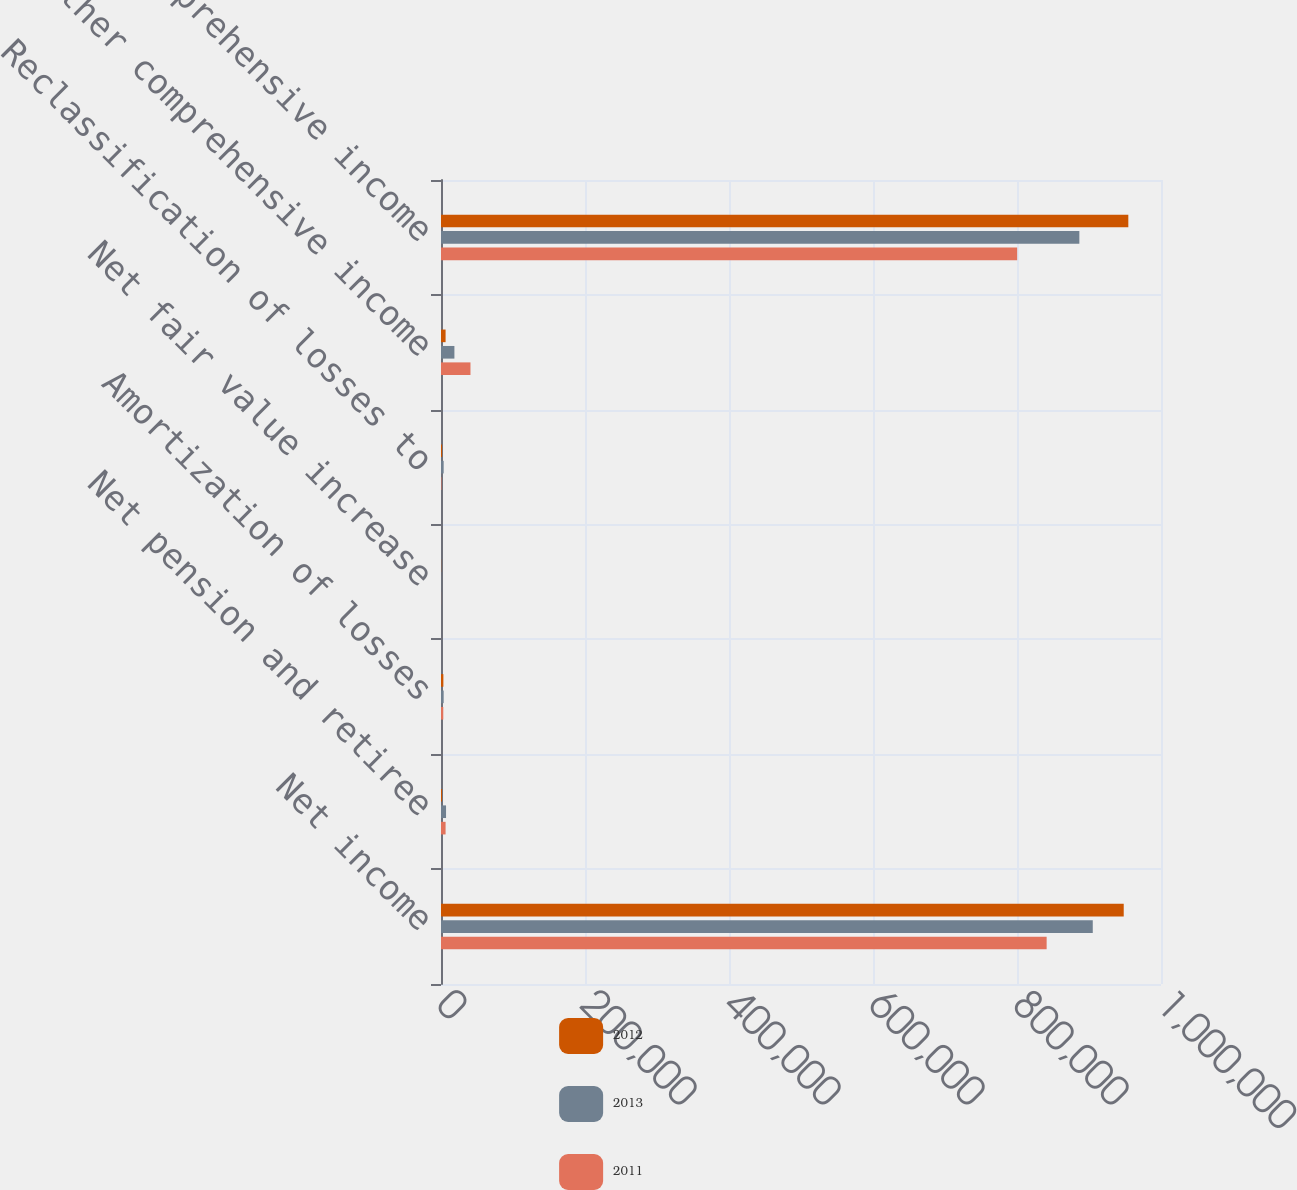Convert chart. <chart><loc_0><loc_0><loc_500><loc_500><stacked_bar_chart><ecel><fcel>Net income<fcel>Net pension and retiree<fcel>Amortization of losses<fcel>Net fair value increase<fcel>Reclassification of losses to<fcel>Other comprehensive income<fcel>Comprehensive income<nl><fcel>2012<fcel>948234<fcel>1408<fcel>3306<fcel>176<fcel>1476<fcel>6378<fcel>954612<nl><fcel>2013<fcel>905229<fcel>7005<fcel>3694<fcel>196<fcel>3697<fcel>18618<fcel>886611<nl><fcel>2011<fcel>841172<fcel>6367<fcel>3162<fcel>93<fcel>648<fcel>40942<fcel>800230<nl></chart> 